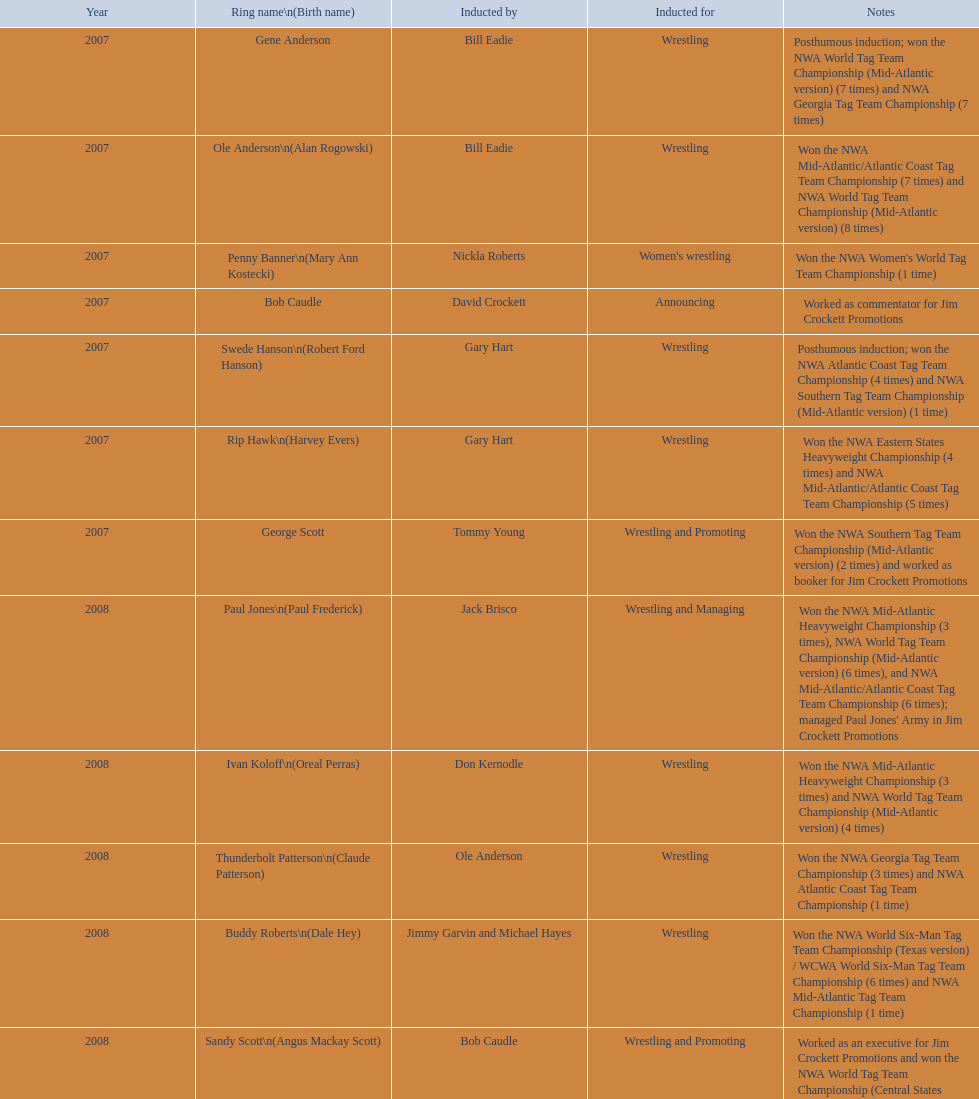Would you be able to parse every entry in this table? {'header': ['Year', 'Ring name\\n(Birth name)', 'Inducted by', 'Inducted for', 'Notes'], 'rows': [['2007', 'Gene Anderson', 'Bill Eadie', 'Wrestling', 'Posthumous induction; won the NWA World Tag Team Championship (Mid-Atlantic version) (7 times) and NWA Georgia Tag Team Championship (7 times)'], ['2007', 'Ole Anderson\\n(Alan Rogowski)', 'Bill Eadie', 'Wrestling', 'Won the NWA Mid-Atlantic/Atlantic Coast Tag Team Championship (7 times) and NWA World Tag Team Championship (Mid-Atlantic version) (8 times)'], ['2007', 'Penny Banner\\n(Mary Ann Kostecki)', 'Nickla Roberts', "Women's wrestling", "Won the NWA Women's World Tag Team Championship (1 time)"], ['2007', 'Bob Caudle', 'David Crockett', 'Announcing', 'Worked as commentator for Jim Crockett Promotions'], ['2007', 'Swede Hanson\\n(Robert Ford Hanson)', 'Gary Hart', 'Wrestling', 'Posthumous induction; won the NWA Atlantic Coast Tag Team Championship (4 times) and NWA Southern Tag Team Championship (Mid-Atlantic version) (1 time)'], ['2007', 'Rip Hawk\\n(Harvey Evers)', 'Gary Hart', 'Wrestling', 'Won the NWA Eastern States Heavyweight Championship (4 times) and NWA Mid-Atlantic/Atlantic Coast Tag Team Championship (5 times)'], ['2007', 'George Scott', 'Tommy Young', 'Wrestling and Promoting', 'Won the NWA Southern Tag Team Championship (Mid-Atlantic version) (2 times) and worked as booker for Jim Crockett Promotions'], ['2008', 'Paul Jones\\n(Paul Frederick)', 'Jack Brisco', 'Wrestling and Managing', "Won the NWA Mid-Atlantic Heavyweight Championship (3 times), NWA World Tag Team Championship (Mid-Atlantic version) (6 times), and NWA Mid-Atlantic/Atlantic Coast Tag Team Championship (6 times); managed Paul Jones' Army in Jim Crockett Promotions"], ['2008', 'Ivan Koloff\\n(Oreal Perras)', 'Don Kernodle', 'Wrestling', 'Won the NWA Mid-Atlantic Heavyweight Championship (3 times) and NWA World Tag Team Championship (Mid-Atlantic version) (4 times)'], ['2008', 'Thunderbolt Patterson\\n(Claude Patterson)', 'Ole Anderson', 'Wrestling', 'Won the NWA Georgia Tag Team Championship (3 times) and NWA Atlantic Coast Tag Team Championship (1 time)'], ['2008', 'Buddy Roberts\\n(Dale Hey)', 'Jimmy Garvin and Michael Hayes', 'Wrestling', 'Won the NWA World Six-Man Tag Team Championship (Texas version) / WCWA World Six-Man Tag Team Championship (6 times) and NWA Mid-Atlantic Tag Team Championship (1 time)'], ['2008', 'Sandy Scott\\n(Angus Mackay Scott)', 'Bob Caudle', 'Wrestling and Promoting', 'Worked as an executive for Jim Crockett Promotions and won the NWA World Tag Team Championship (Central States version) (1 time) and NWA Southern Tag Team Championship (Mid-Atlantic version) (3 times)'], ['2008', 'Grizzly Smith\\n(Aurelian Smith)', 'Magnum T.A.', 'Wrestling', 'Won the NWA United States Tag Team Championship (Tri-State version) (2 times) and NWA Texas Heavyweight Championship (1 time)'], ['2008', 'Johnny Weaver\\n(Kenneth Eugene Weaver)', 'Rip Hawk', 'Wrestling', 'Posthumous induction; won the NWA Atlantic Coast/Mid-Atlantic Tag Team Championship (8 times) and NWA Southern Tag Team Championship (Mid-Atlantic version) (6 times)'], ['2009', 'Don Fargo\\n(Don Kalt)', 'Jerry Jarrett & Steve Keirn', 'Wrestling', 'Won the NWA Southern Tag Team Championship (Mid-America version) (2 times) and NWA World Tag Team Championship (Mid-America version) (6 times)'], ['2009', 'Jackie Fargo\\n(Henry Faggart)', 'Jerry Jarrett & Steve Keirn', 'Wrestling', 'Won the NWA World Tag Team Championship (Mid-America version) (10 times) and NWA Southern Tag Team Championship (Mid-America version) (22 times)'], ['2009', 'Sonny Fargo\\n(Jack Lewis Faggart)', 'Jerry Jarrett & Steve Keirn', 'Wrestling', 'Posthumous induction; won the NWA Southern Tag Team Championship (Mid-America version) (3 times)'], ['2009', 'Gary Hart\\n(Gary Williams)', 'Sir Oliver Humperdink', 'Managing and Promoting', 'Posthumous induction; worked as a booker in World Class Championship Wrestling and managed several wrestlers in Mid-Atlantic Championship Wrestling'], ['2009', 'Wahoo McDaniel\\n(Edward McDaniel)', 'Tully Blanchard', 'Wrestling', 'Posthumous induction; won the NWA Mid-Atlantic Heavyweight Championship (6 times) and NWA World Tag Team Championship (Mid-Atlantic version) (4 times)'], ['2009', 'Blackjack Mulligan\\n(Robert Windham)', 'Ric Flair', 'Wrestling', 'Won the NWA Texas Heavyweight Championship (1 time) and NWA World Tag Team Championship (Mid-Atlantic version) (1 time)'], ['2009', 'Nelson Royal', 'Brad Anderson, Tommy Angel & David Isley', 'Wrestling', 'Won the NWA Atlantic Coast Tag Team Championship (2 times)'], ['2009', 'Lance Russell', 'Dave Brown', 'Announcing', 'Worked as commentator for wrestling events in the Memphis area']]} How many members were brought in for announcing? 2. 